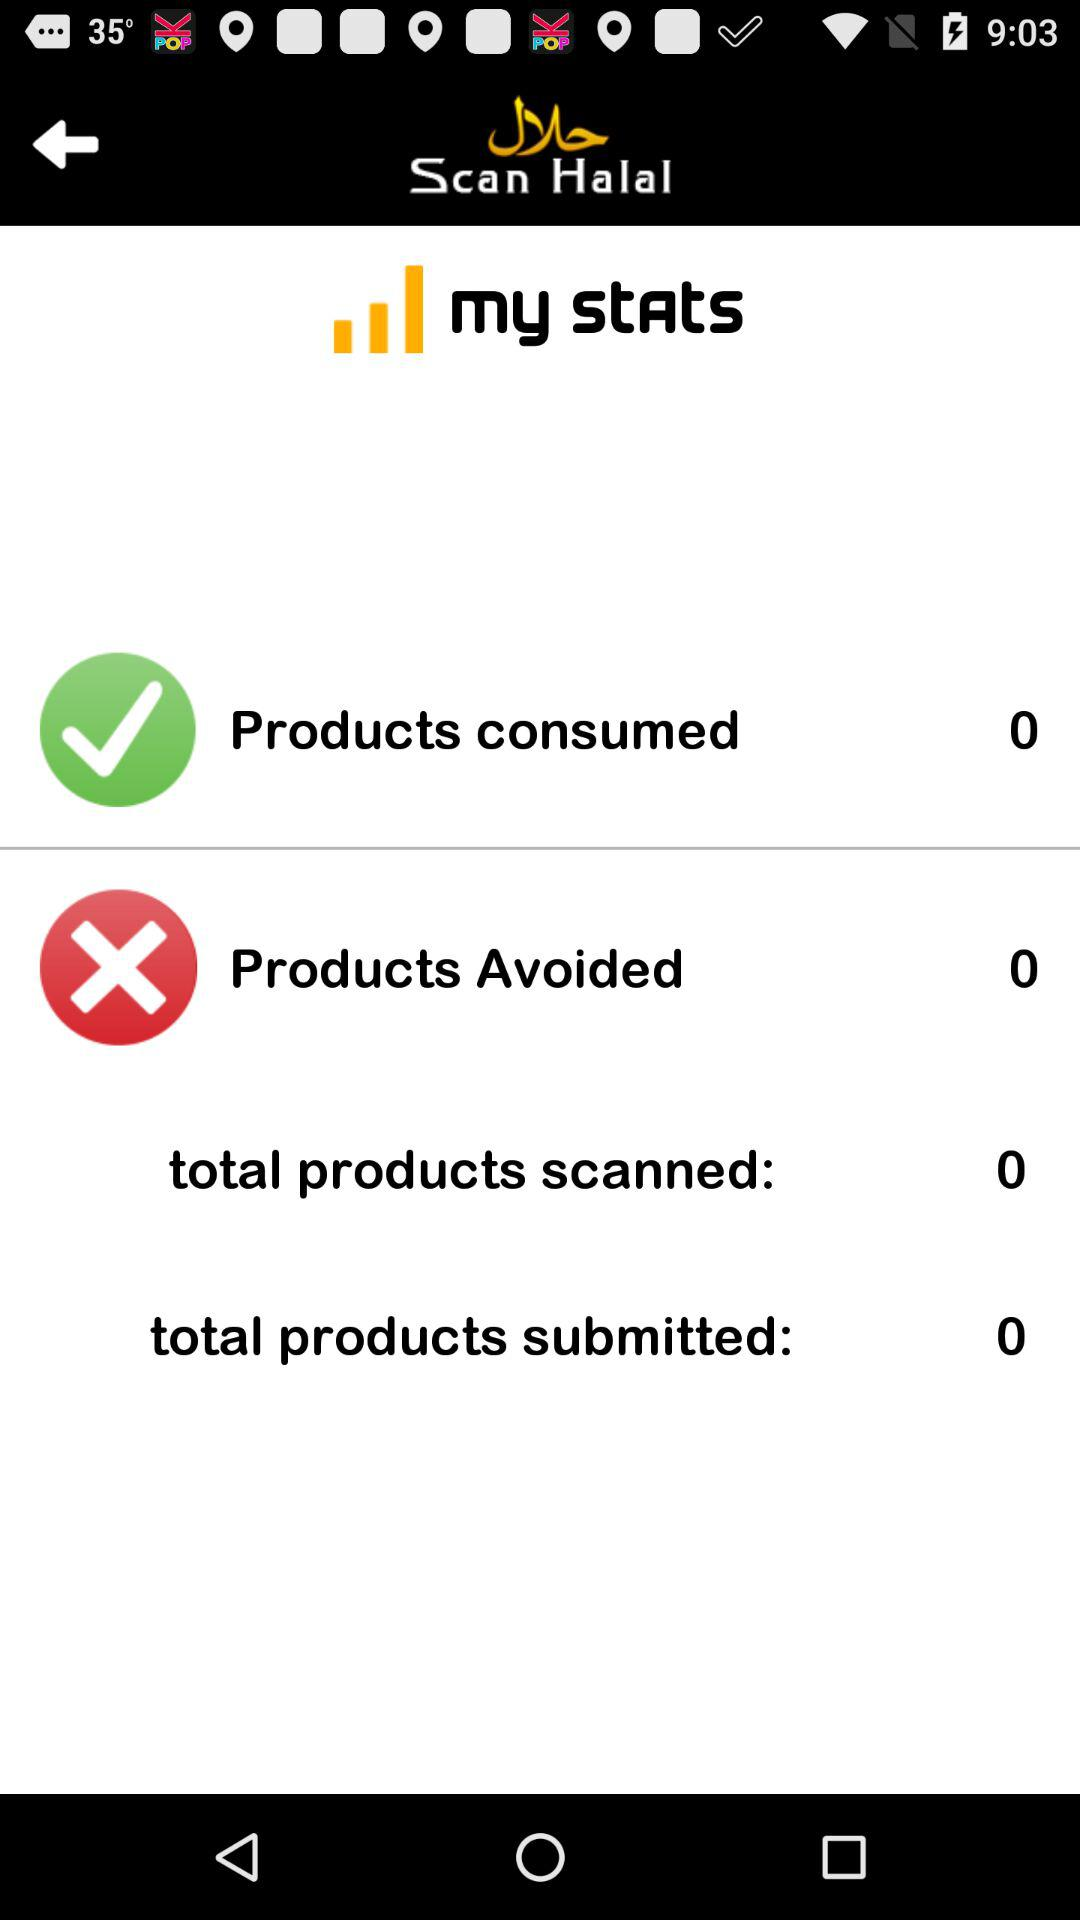What is the application name? The application name is "Scan Halal". 